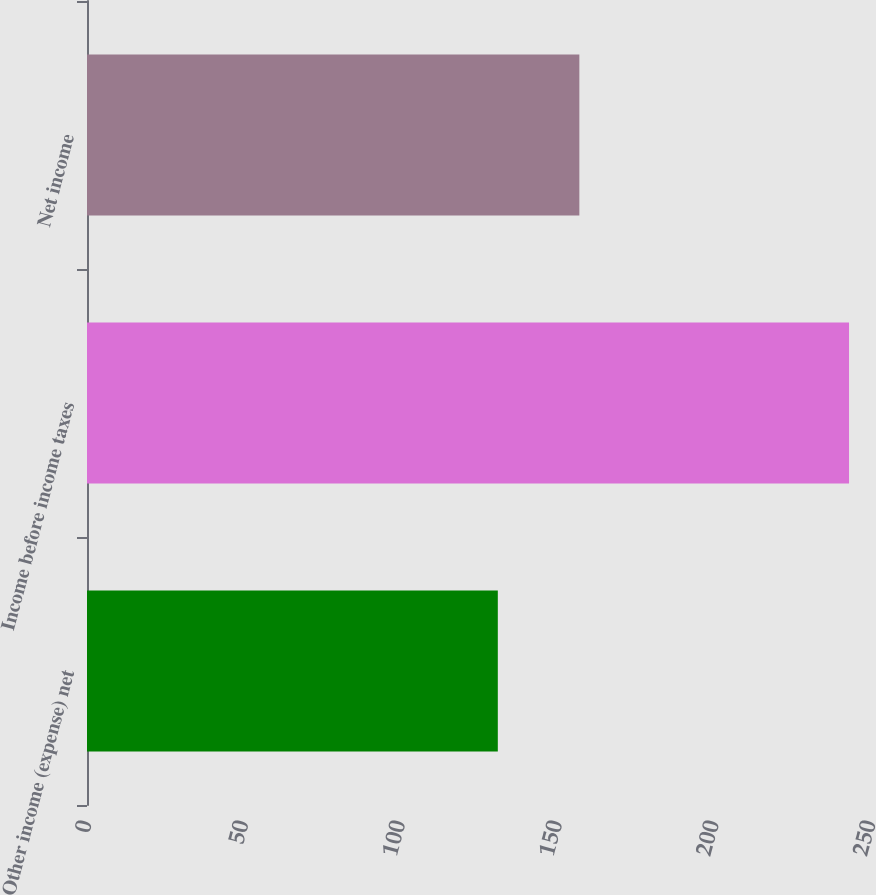<chart> <loc_0><loc_0><loc_500><loc_500><bar_chart><fcel>Other income (expense) net<fcel>Income before income taxes<fcel>Net income<nl><fcel>131<fcel>243<fcel>157<nl></chart> 